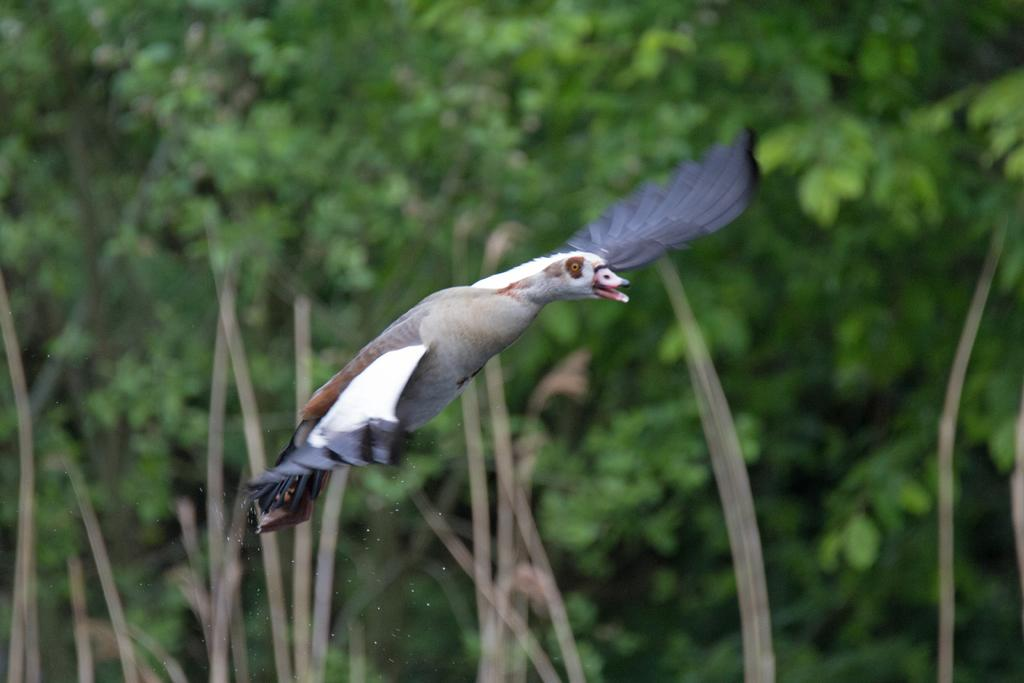What type of animal can be seen in the image? There is a bird in the image. What is the bird doing in the image? The bird is flying in the air. What color is the background of the bird? The background of the bird is blue. Can you tell me how deep the hole is that the bird is swimming in? There is no hole present in the image, and the bird is not swimming; it is flying in the air. 